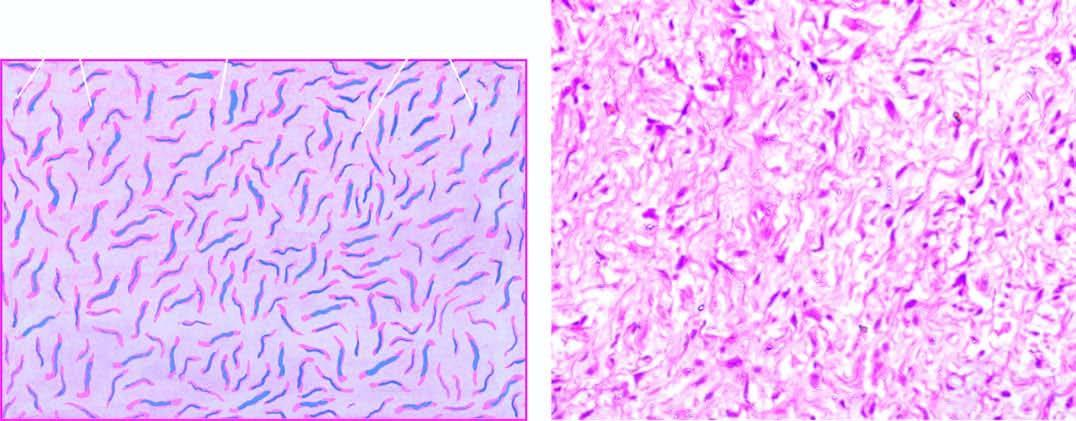re many of the tumour cells separated by mucoid matrix?
Answer the question using a single word or phrase. No 